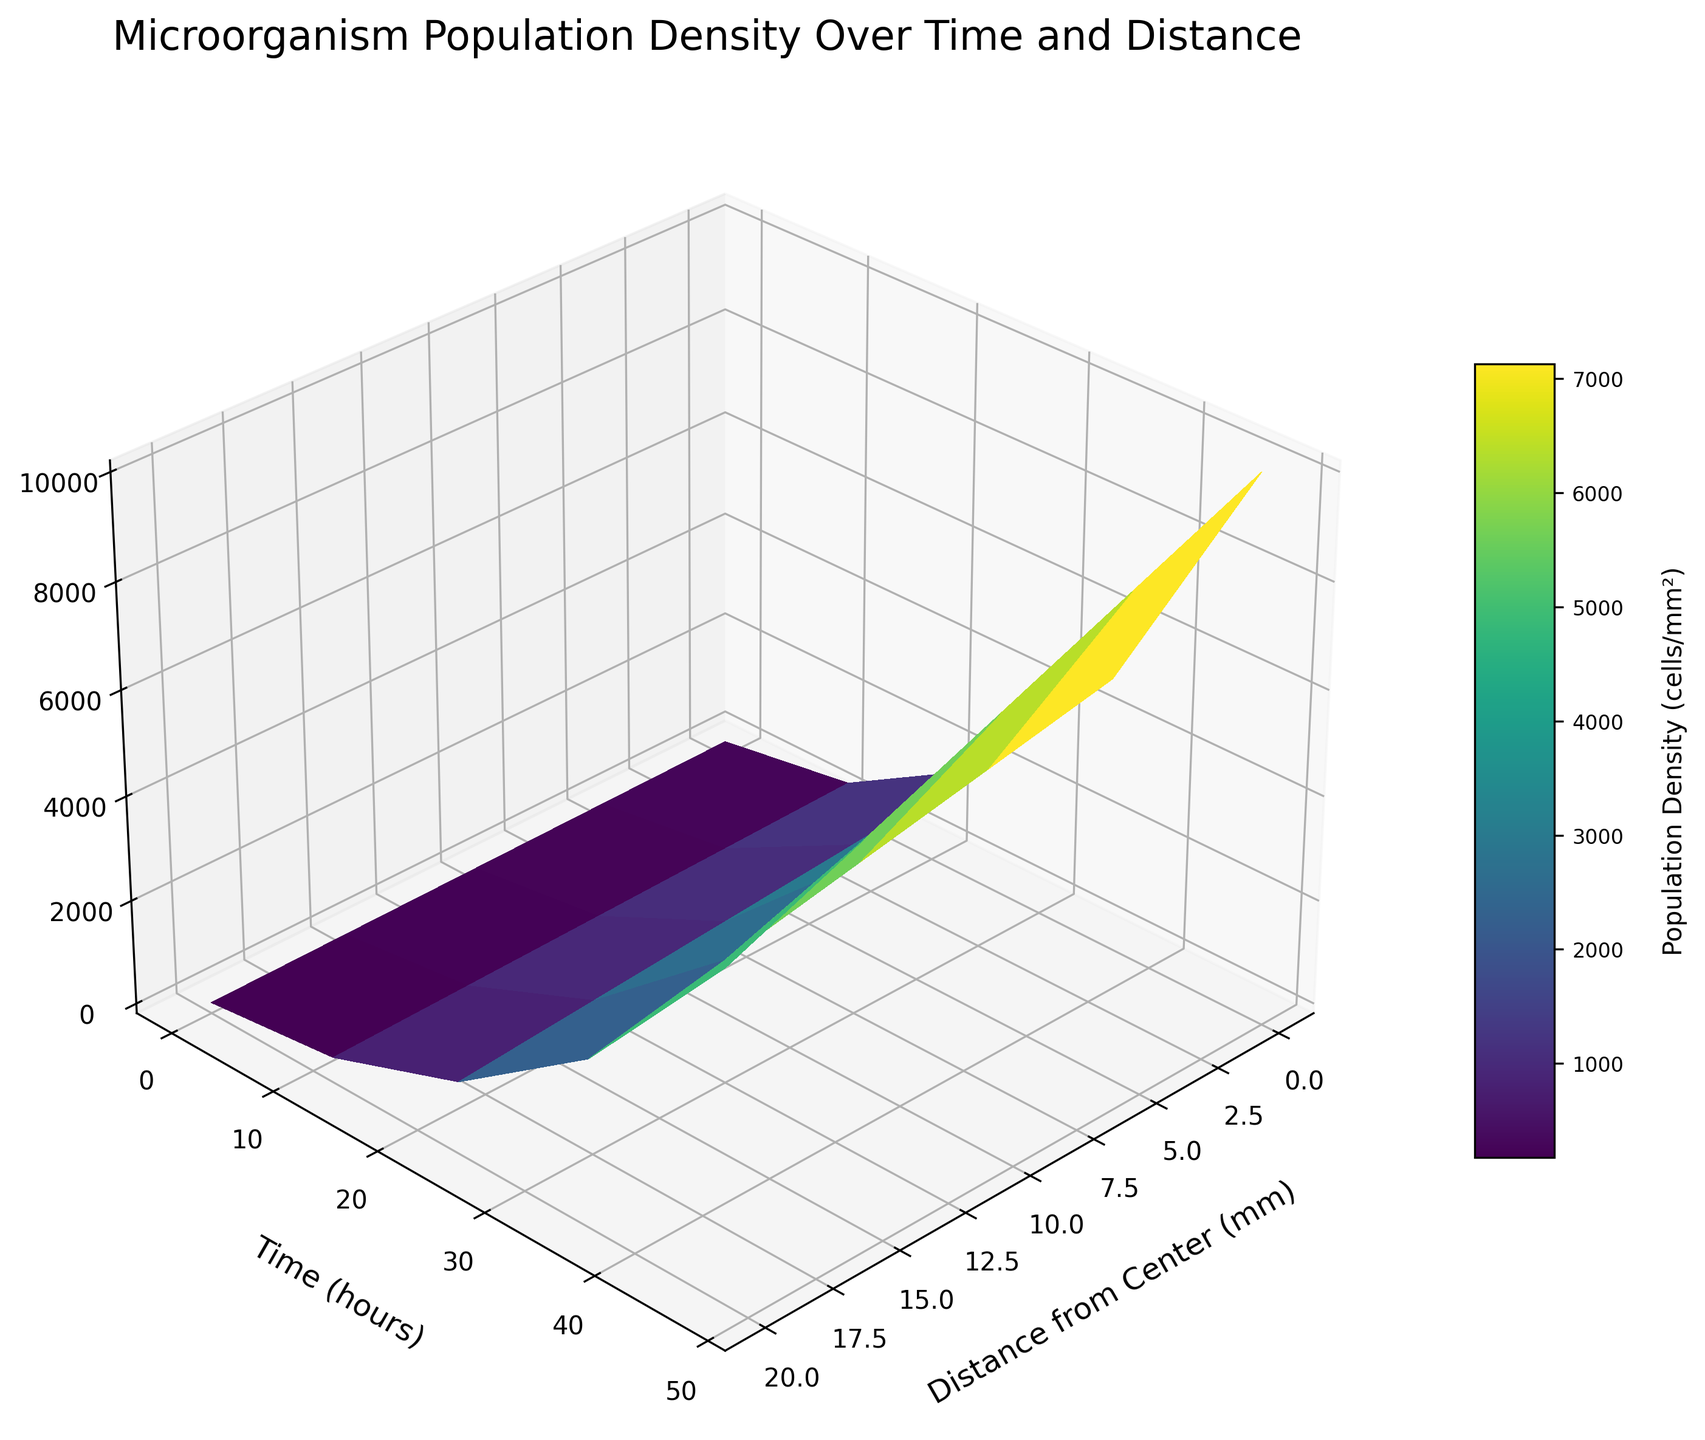what is the title of the plot? The plot's title is written at the top in larger font. It is: "Microorganism Population Density Over Time and Distance"
Answer: Microorganism Population Density Over Time and Distance What's the population density at the center after 36 hours? To find this value, you look at the point corresponding to a distance of 0 mm and a time of 36 hours. The population density value at this point on the surface plot is 5000 cells/mm²
Answer: 5000 cells/mm² How does the population density at 20 mm change from 0 to 48 hours? Look at the line where the distance is 20 mm and observe the population density values as time increases from 0 to 48 hours: they go from 20 cells/mm² to 6000 cells/mm².
Answer: from 20 cells/mm² to 6000 cells/mm² What is the primary color used to represent the highest population density on the plot? The highest population density on the plot, which is 10000 cells/mm², is represented using the color from the highest end of the color map (viridis), which is usually yellow.
Answer: yellow At what time did the population density first exceed 1000 cells/mm² at 10 mm from the center? Find the point where the distance is 10 mm and observe the time when the population density first exceeds 1000 cells/mm². At time 24 hours, the density is 1600 cells/mm².
Answer: 24 hours Which time point shows the largest variation in population density across the distances from the center? Look at the changes in population density from 0 to 20 mm at each time point. At 48 hours, the population density ranges from 10000 cells/mm² at 0 mm to 6000 cells/mm² at 20 mm, showing a variation of 4000 cells/mm².
Answer: 48 hours What's the difference in population density at the center between 12 and 24 hours? Observe the population density at 0 mm for 12 hours (500 cells/mm²) and at 24 hours (2000 cells/mm²). The difference is 2000 - 500 = 1500 cells/mm².
Answer: 1500 cells/mm² When is the population density the same at 5 mm and 15 mm from the center? Compare the values for 5 mm and 15 mm along the time axis. At 12 hours, they are different, but at 24 hours, they are 1800 cells/mm² and 1400 cells/mm², respectively. Continue this comparison to see there is no matching time point.
Answer: no matching time What's the average population density at 10 mm from the center across all time points? Sum the population densities at 10 mm from the center (60, 400, 1600, 4000, 8000) and divide by the number of time points (5): (60 + 400 + 1600 + 4000 + 8000) / 5 = 2812 cells/mm².
Answer: 2812 cells/mm² 